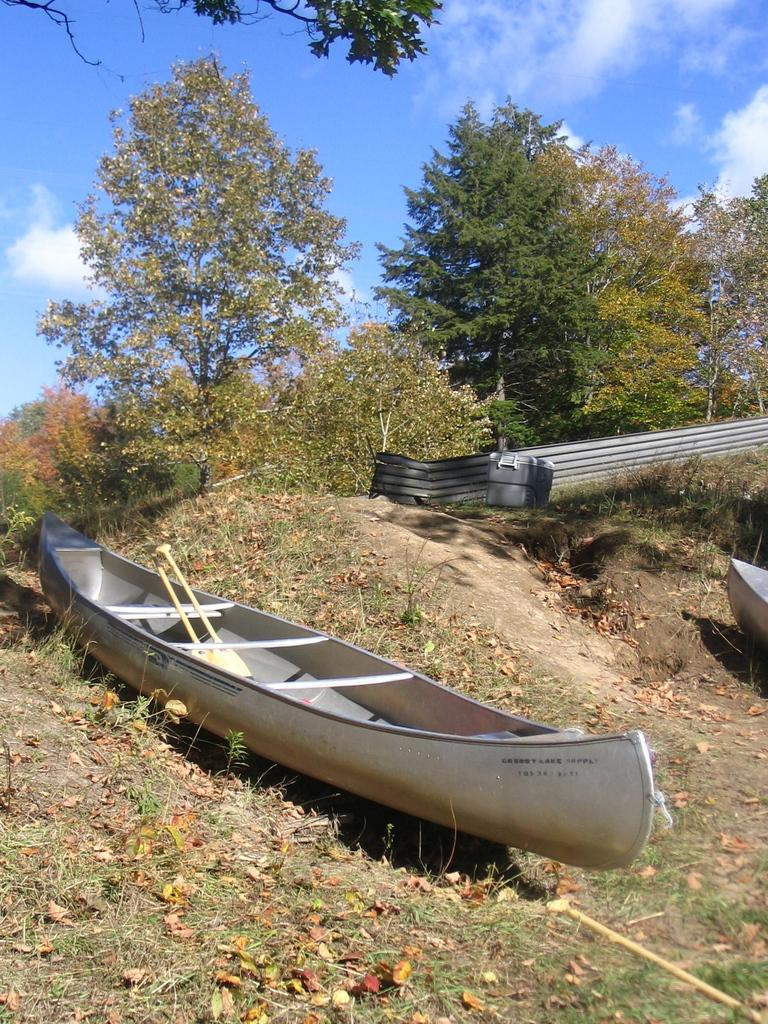What is the main subject of the image? The main subject of the image is a boat. What type of natural environment is visible in the image? There are trees in the image, which suggests a natural setting. What is visible in the sky in the image? The sky is visible in the image, and there are clouds present. What type of account does the boat have with the clouds in the image? There is no indication in the image that the boat has any type of account with the clouds. What experience can be gained from observing the boat and clouds in the image? The image is a static representation and does not provide any direct experience. 